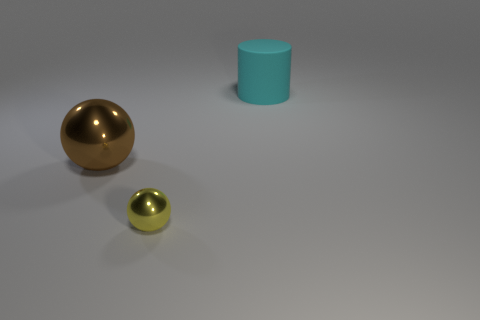Are there any other things that have the same material as the large cylinder?
Offer a very short reply. No. How many matte things are in front of the sphere that is to the right of the large ball?
Keep it short and to the point. 0. Is the number of shiny balls right of the big brown ball greater than the number of large cyan matte cylinders in front of the small sphere?
Keep it short and to the point. Yes. What material is the big cyan thing?
Provide a succinct answer. Rubber. Are there any brown balls of the same size as the cyan cylinder?
Make the answer very short. Yes. What is the material of the brown thing that is the same size as the rubber cylinder?
Make the answer very short. Metal. How many large brown metallic cubes are there?
Offer a terse response. 0. What size is the cyan cylinder that is on the right side of the brown ball?
Offer a terse response. Large. Are there the same number of large metallic balls to the right of the cyan cylinder and large brown matte cylinders?
Offer a very short reply. Yes. Is there another large matte object of the same shape as the large cyan rubber thing?
Offer a terse response. No. 